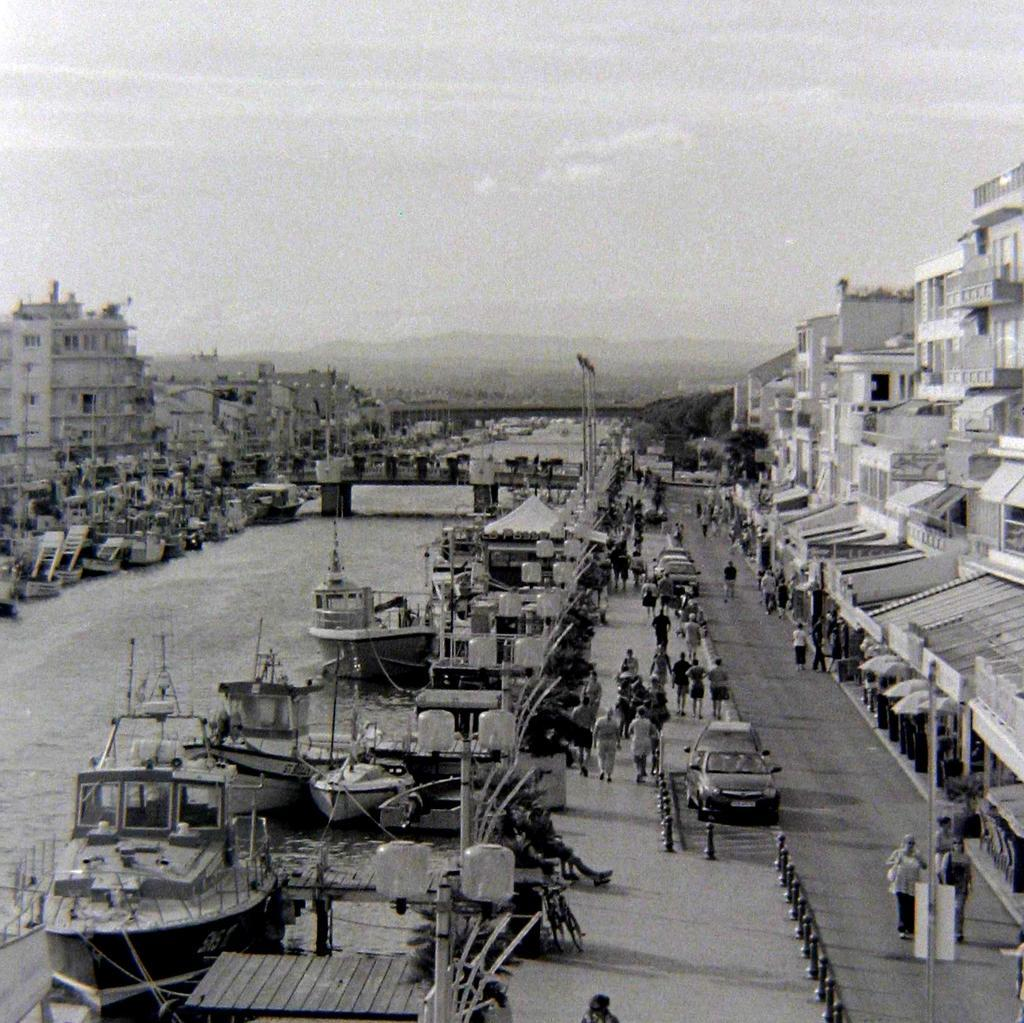What can be seen in the center of the image? The sky is visible in the center of the image. What type of natural elements are present in the image? There are trees in the image. What type of man-made structures can be seen in the image? There are buildings in the image. What type of vertical structures are present in the image? There are poles in the image. What type of transportation is present on the water in the image? There are boats on the water in the image. What type of transportation is present on land in the image? There are vehicles in the image. What type of human activity can be seen in the image? There are people sitting and people walking in the image. What other objects can be seen in the image? There are other objects in the image. What type of shirt is the coach wearing in the image? There is no coach or shirt present in the image. 